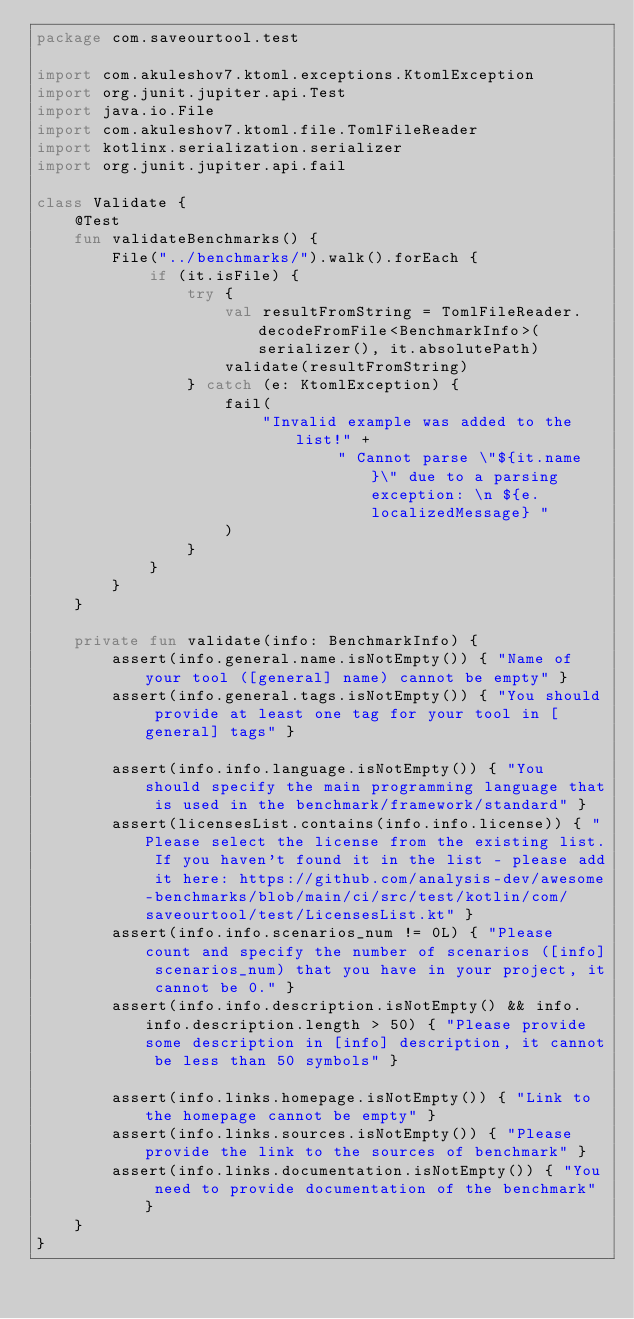<code> <loc_0><loc_0><loc_500><loc_500><_Kotlin_>package com.saveourtool.test

import com.akuleshov7.ktoml.exceptions.KtomlException
import org.junit.jupiter.api.Test
import java.io.File
import com.akuleshov7.ktoml.file.TomlFileReader
import kotlinx.serialization.serializer
import org.junit.jupiter.api.fail

class Validate {
    @Test
    fun validateBenchmarks() {
        File("../benchmarks/").walk().forEach {
            if (it.isFile) {
                try {
                    val resultFromString = TomlFileReader.decodeFromFile<BenchmarkInfo>(serializer(), it.absolutePath)
                    validate(resultFromString)
                } catch (e: KtomlException) {
                    fail(
                        "Invalid example was added to the list!" +
                                " Cannot parse \"${it.name}\" due to a parsing exception: \n ${e.localizedMessage} "
                    )
                }
            }
        }
    }

    private fun validate(info: BenchmarkInfo) {
        assert(info.general.name.isNotEmpty()) { "Name of your tool ([general] name) cannot be empty" }
        assert(info.general.tags.isNotEmpty()) { "You should provide at least one tag for your tool in [general] tags" }

        assert(info.info.language.isNotEmpty()) { "You should specify the main programming language that is used in the benchmark/framework/standard" }
        assert(licensesList.contains(info.info.license)) { "Please select the license from the existing list. If you haven't found it in the list - please add it here: https://github.com/analysis-dev/awesome-benchmarks/blob/main/ci/src/test/kotlin/com/saveourtool/test/LicensesList.kt" }
        assert(info.info.scenarios_num != 0L) { "Please count and specify the number of scenarios ([info] scenarios_num) that you have in your project, it cannot be 0." }
        assert(info.info.description.isNotEmpty() && info.info.description.length > 50) { "Please provide some description in [info] description, it cannot be less than 50 symbols" }

        assert(info.links.homepage.isNotEmpty()) { "Link to the homepage cannot be empty" }
        assert(info.links.sources.isNotEmpty()) { "Please provide the link to the sources of benchmark" }
        assert(info.links.documentation.isNotEmpty()) { "You need to provide documentation of the benchmark" }
    }
}
</code> 